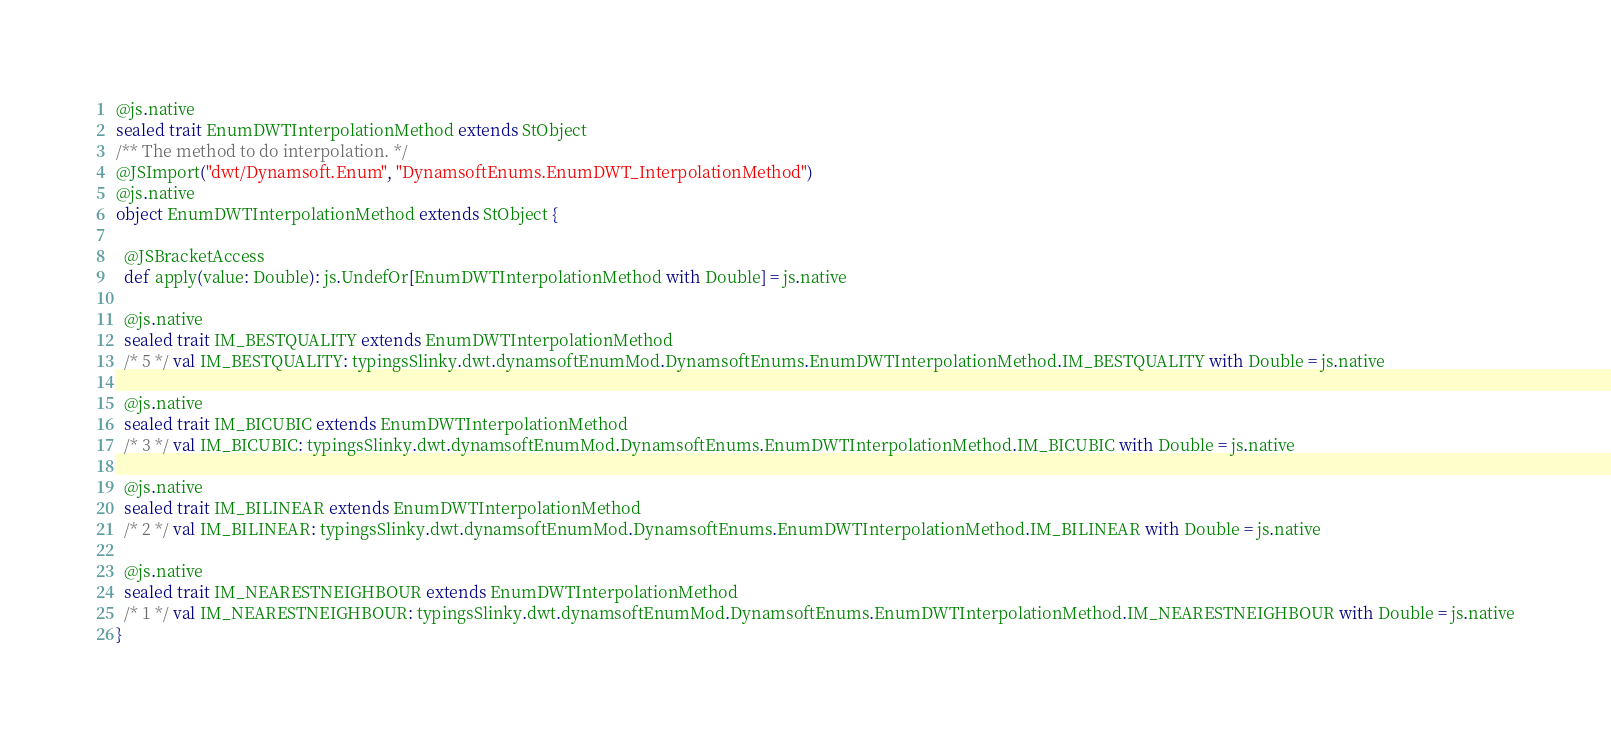<code> <loc_0><loc_0><loc_500><loc_500><_Scala_>
@js.native
sealed trait EnumDWTInterpolationMethod extends StObject
/** The method to do interpolation. */
@JSImport("dwt/Dynamsoft.Enum", "DynamsoftEnums.EnumDWT_InterpolationMethod")
@js.native
object EnumDWTInterpolationMethod extends StObject {
  
  @JSBracketAccess
  def apply(value: Double): js.UndefOr[EnumDWTInterpolationMethod with Double] = js.native
  
  @js.native
  sealed trait IM_BESTQUALITY extends EnumDWTInterpolationMethod
  /* 5 */ val IM_BESTQUALITY: typingsSlinky.dwt.dynamsoftEnumMod.DynamsoftEnums.EnumDWTInterpolationMethod.IM_BESTQUALITY with Double = js.native
  
  @js.native
  sealed trait IM_BICUBIC extends EnumDWTInterpolationMethod
  /* 3 */ val IM_BICUBIC: typingsSlinky.dwt.dynamsoftEnumMod.DynamsoftEnums.EnumDWTInterpolationMethod.IM_BICUBIC with Double = js.native
  
  @js.native
  sealed trait IM_BILINEAR extends EnumDWTInterpolationMethod
  /* 2 */ val IM_BILINEAR: typingsSlinky.dwt.dynamsoftEnumMod.DynamsoftEnums.EnumDWTInterpolationMethod.IM_BILINEAR with Double = js.native
  
  @js.native
  sealed trait IM_NEARESTNEIGHBOUR extends EnumDWTInterpolationMethod
  /* 1 */ val IM_NEARESTNEIGHBOUR: typingsSlinky.dwt.dynamsoftEnumMod.DynamsoftEnums.EnumDWTInterpolationMethod.IM_NEARESTNEIGHBOUR with Double = js.native
}
</code> 